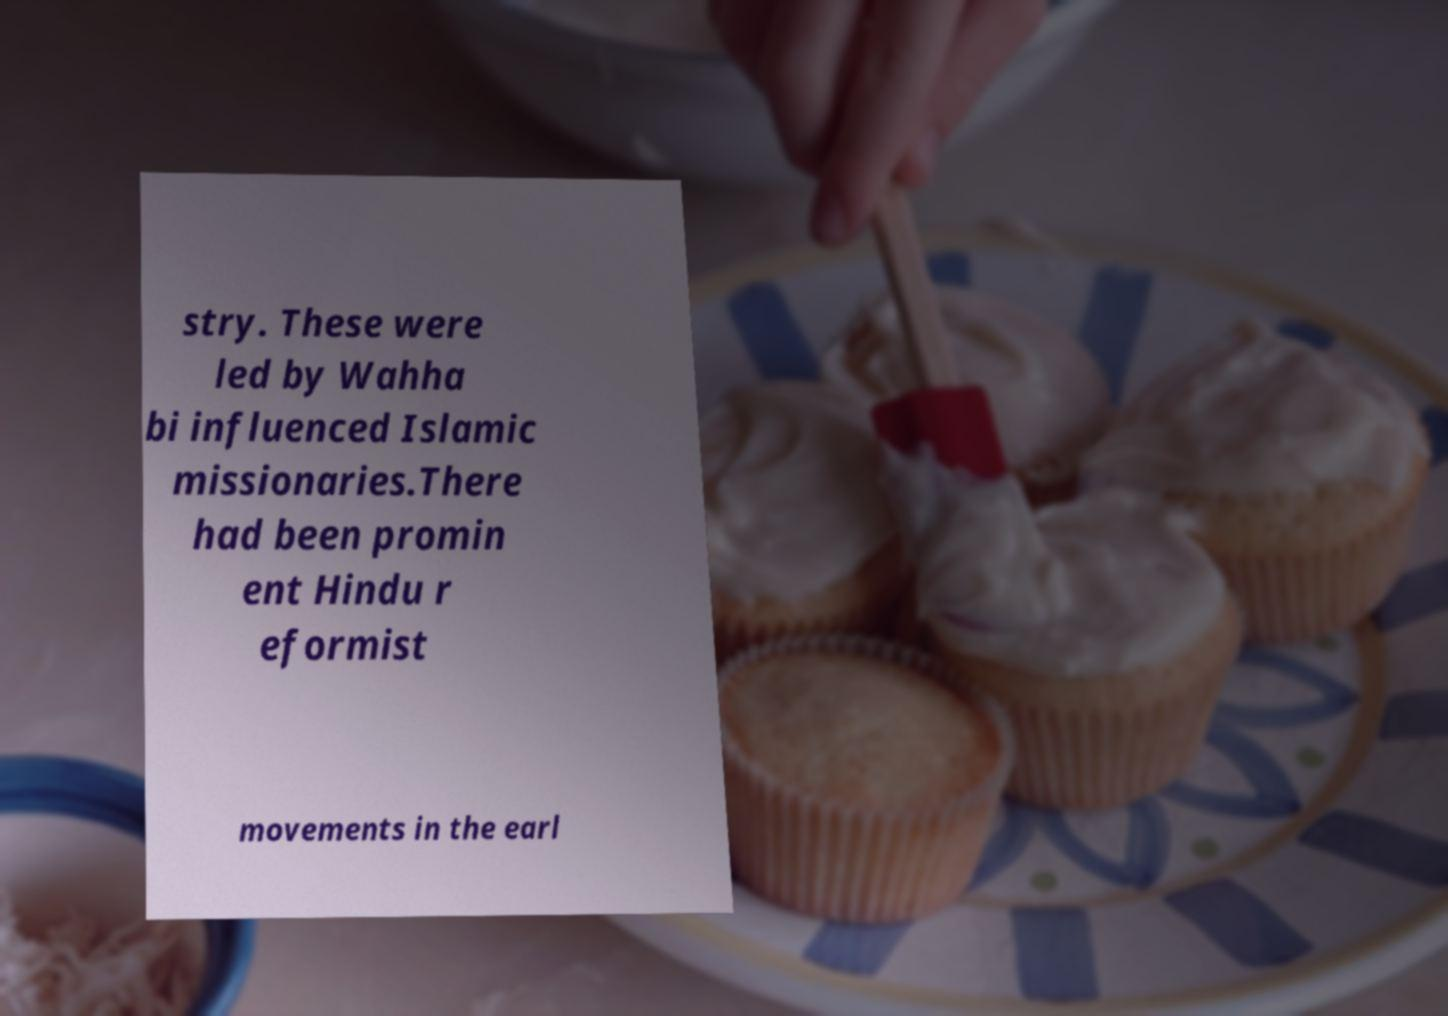Can you read and provide the text displayed in the image?This photo seems to have some interesting text. Can you extract and type it out for me? stry. These were led by Wahha bi influenced Islamic missionaries.There had been promin ent Hindu r eformist movements in the earl 